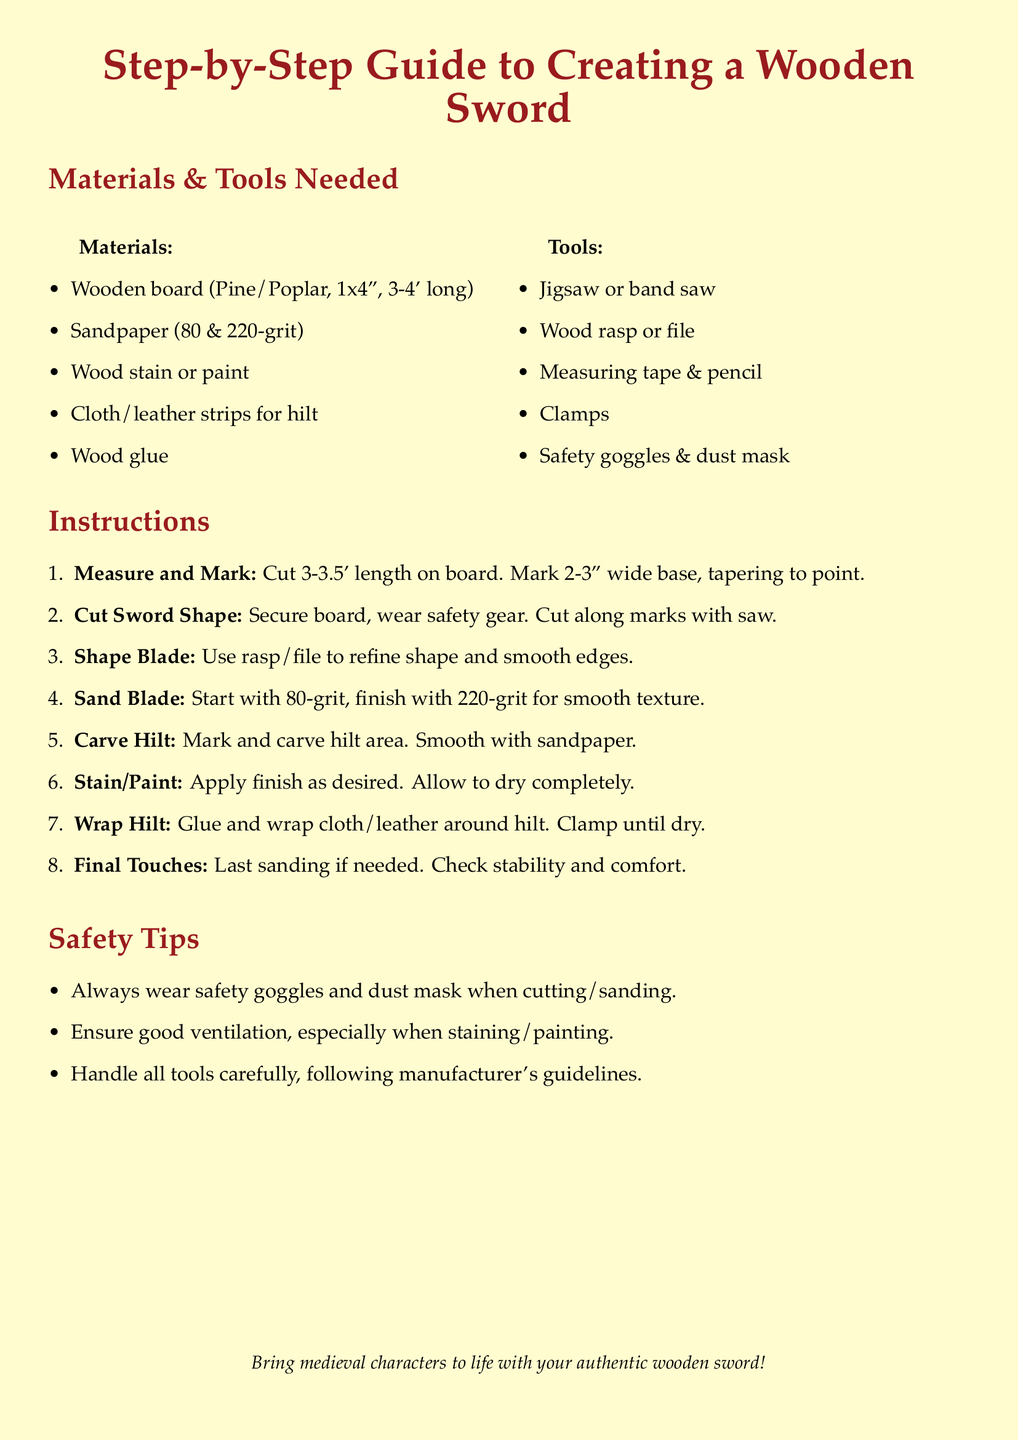What is the length of the wooden board needed? The document specifies the board should be 3-4 feet long.
Answer: 3-4' What grit sandpaper is recommended for finishing? The instructions mention using 80 and 220-grit sandpaper for smoothing.
Answer: 80 & 220-grit What type of wood is suggested for the sword? The materials list states to use Pine or Poplar for the wooden board.
Answer: Pine/Poplar How many steps are there in the sword creation process? The instructions enumerate a total of 8 distinct steps in the process.
Answer: 8 What should be done after applying stain or paint? The instructions indicate that the applied finish should be allowed to dry completely.
Answer: Allow to dry completely What safety equipment is required when using tools? The document clearly states that safety goggles and a dust mask must be worn.
Answer: Safety goggles & dust mask 